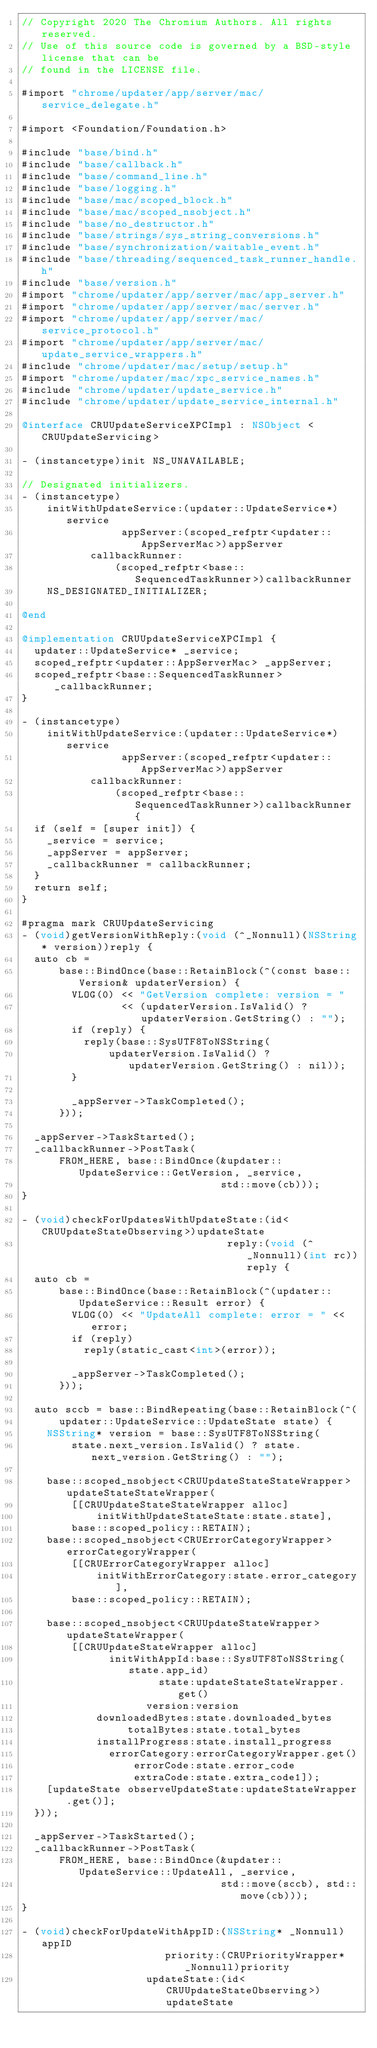<code> <loc_0><loc_0><loc_500><loc_500><_ObjectiveC_>// Copyright 2020 The Chromium Authors. All rights reserved.
// Use of this source code is governed by a BSD-style license that can be
// found in the LICENSE file.

#import "chrome/updater/app/server/mac/service_delegate.h"

#import <Foundation/Foundation.h>

#include "base/bind.h"
#include "base/callback.h"
#include "base/command_line.h"
#include "base/logging.h"
#include "base/mac/scoped_block.h"
#include "base/mac/scoped_nsobject.h"
#include "base/no_destructor.h"
#include "base/strings/sys_string_conversions.h"
#include "base/synchronization/waitable_event.h"
#include "base/threading/sequenced_task_runner_handle.h"
#include "base/version.h"
#import "chrome/updater/app/server/mac/app_server.h"
#import "chrome/updater/app/server/mac/server.h"
#import "chrome/updater/app/server/mac/service_protocol.h"
#import "chrome/updater/app/server/mac/update_service_wrappers.h"
#include "chrome/updater/mac/setup/setup.h"
#import "chrome/updater/mac/xpc_service_names.h"
#include "chrome/updater/update_service.h"
#include "chrome/updater/update_service_internal.h"

@interface CRUUpdateServiceXPCImpl : NSObject <CRUUpdateServicing>

- (instancetype)init NS_UNAVAILABLE;

// Designated initializers.
- (instancetype)
    initWithUpdateService:(updater::UpdateService*)service
                appServer:(scoped_refptr<updater::AppServerMac>)appServer
           callbackRunner:
               (scoped_refptr<base::SequencedTaskRunner>)callbackRunner
    NS_DESIGNATED_INITIALIZER;

@end

@implementation CRUUpdateServiceXPCImpl {
  updater::UpdateService* _service;
  scoped_refptr<updater::AppServerMac> _appServer;
  scoped_refptr<base::SequencedTaskRunner> _callbackRunner;
}

- (instancetype)
    initWithUpdateService:(updater::UpdateService*)service
                appServer:(scoped_refptr<updater::AppServerMac>)appServer
           callbackRunner:
               (scoped_refptr<base::SequencedTaskRunner>)callbackRunner {
  if (self = [super init]) {
    _service = service;
    _appServer = appServer;
    _callbackRunner = callbackRunner;
  }
  return self;
}

#pragma mark CRUUpdateServicing
- (void)getVersionWithReply:(void (^_Nonnull)(NSString* version))reply {
  auto cb =
      base::BindOnce(base::RetainBlock(^(const base::Version& updaterVersion) {
        VLOG(0) << "GetVersion complete: version = "
                << (updaterVersion.IsValid() ? updaterVersion.GetString() : "");
        if (reply) {
          reply(base::SysUTF8ToNSString(
              updaterVersion.IsValid() ? updaterVersion.GetString() : nil));
        }

        _appServer->TaskCompleted();
      }));

  _appServer->TaskStarted();
  _callbackRunner->PostTask(
      FROM_HERE, base::BindOnce(&updater::UpdateService::GetVersion, _service,
                                std::move(cb)));
}

- (void)checkForUpdatesWithUpdateState:(id<CRUUpdateStateObserving>)updateState
                                 reply:(void (^_Nonnull)(int rc))reply {
  auto cb =
      base::BindOnce(base::RetainBlock(^(updater::UpdateService::Result error) {
        VLOG(0) << "UpdateAll complete: error = " << error;
        if (reply)
          reply(static_cast<int>(error));

        _appServer->TaskCompleted();
      }));

  auto sccb = base::BindRepeating(base::RetainBlock(^(
      updater::UpdateService::UpdateState state) {
    NSString* version = base::SysUTF8ToNSString(
        state.next_version.IsValid() ? state.next_version.GetString() : "");

    base::scoped_nsobject<CRUUpdateStateStateWrapper> updateStateStateWrapper(
        [[CRUUpdateStateStateWrapper alloc]
            initWithUpdateStateState:state.state],
        base::scoped_policy::RETAIN);
    base::scoped_nsobject<CRUErrorCategoryWrapper> errorCategoryWrapper(
        [[CRUErrorCategoryWrapper alloc]
            initWithErrorCategory:state.error_category],
        base::scoped_policy::RETAIN);

    base::scoped_nsobject<CRUUpdateStateWrapper> updateStateWrapper(
        [[CRUUpdateStateWrapper alloc]
              initWithAppId:base::SysUTF8ToNSString(state.app_id)
                      state:updateStateStateWrapper.get()
                    version:version
            downloadedBytes:state.downloaded_bytes
                 totalBytes:state.total_bytes
            installProgress:state.install_progress
              errorCategory:errorCategoryWrapper.get()
                  errorCode:state.error_code
                  extraCode:state.extra_code1]);
    [updateState observeUpdateState:updateStateWrapper.get()];
  }));

  _appServer->TaskStarted();
  _callbackRunner->PostTask(
      FROM_HERE, base::BindOnce(&updater::UpdateService::UpdateAll, _service,
                                std::move(sccb), std::move(cb)));
}

- (void)checkForUpdateWithAppID:(NSString* _Nonnull)appID
                       priority:(CRUPriorityWrapper* _Nonnull)priority
                    updateState:(id<CRUUpdateStateObserving>)updateState</code> 